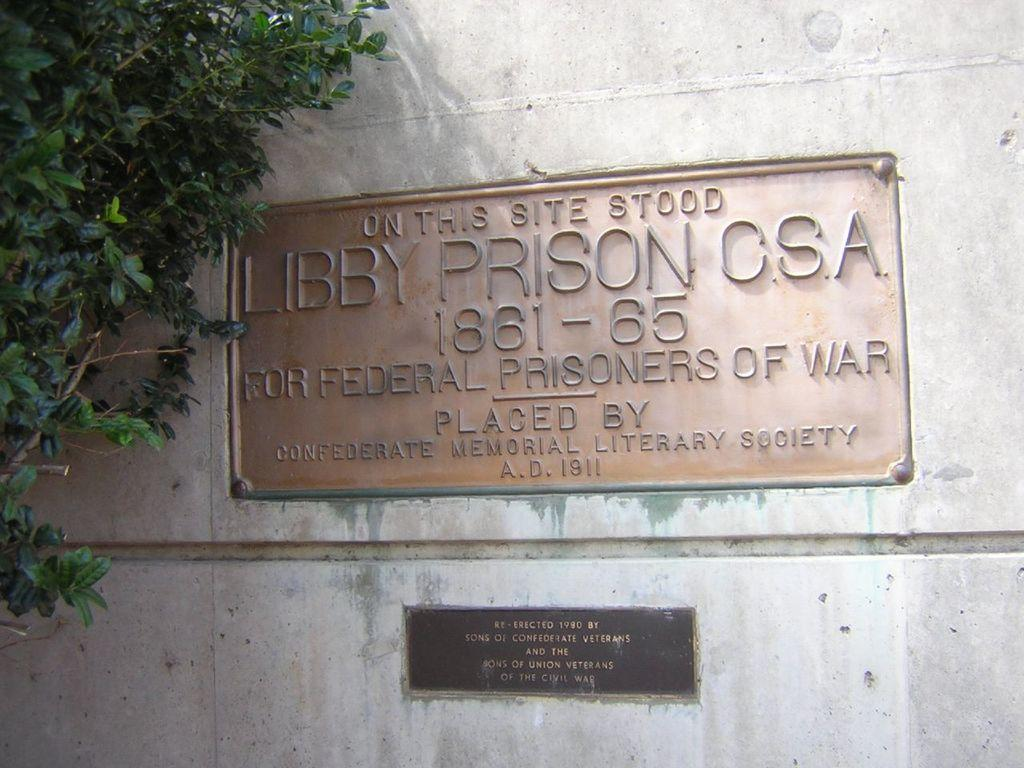What is present on the wall in the image? There are two boards on the wall in the image. What can be seen on the boards? There is text on the boards. Can you describe the tree in the image? The tree is truncated towards the left of the image. Is there a receipt hanging from the tree in the image? There is no receipt present in the image, and the tree is truncated, so it is not possible to hang anything from it. Can you describe the honey dripping from the boards in the image? There is no honey present in the image; only the boards with text and a truncated tree are visible. 